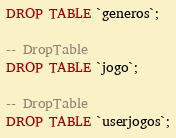Convert code to text. <code><loc_0><loc_0><loc_500><loc_500><_SQL_>DROP TABLE `generos`;

-- DropTable
DROP TABLE `jogo`;

-- DropTable
DROP TABLE `userjogos`;
</code> 